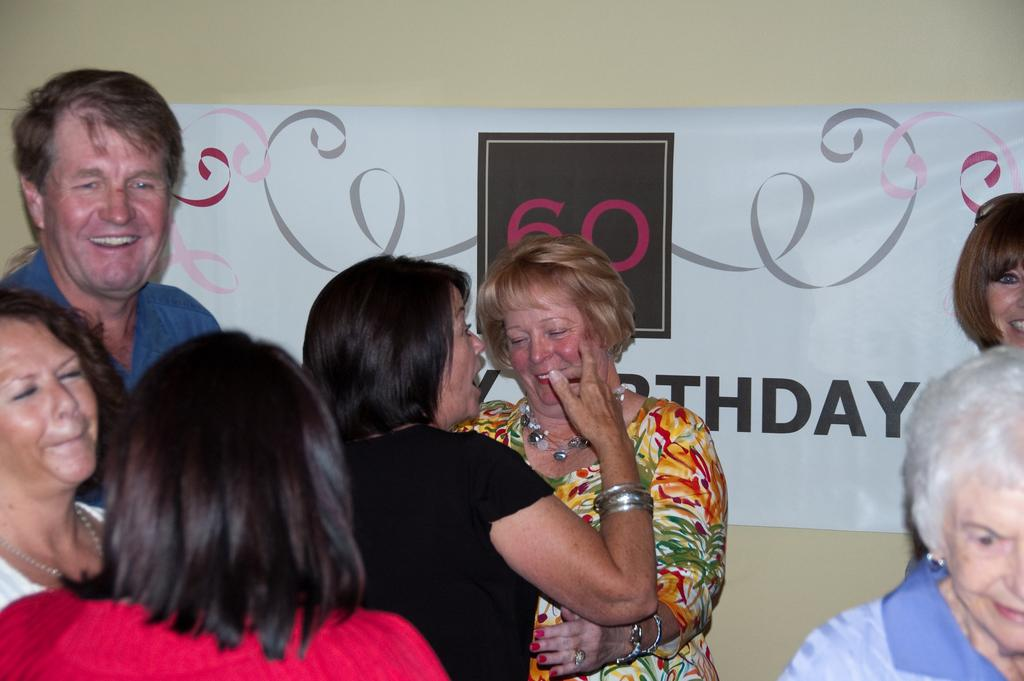What can be seen in the foreground of the image? There are persons standing in the foreground of the image. What is present in the background of the image? There is a banner on the wall in the background of the image. What type of toys can be seen being blown by the wind in the image? There are no toys or wind present in the image. What type of beef is being served at the event in the image? There is no mention of beef or an event in the image. 